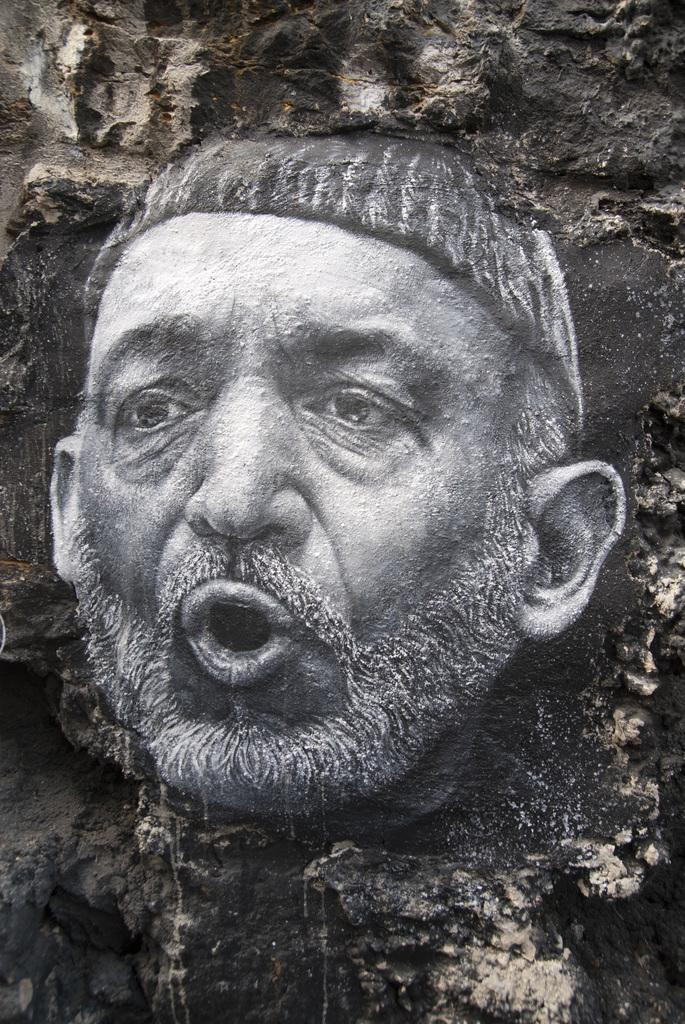What is the main subject of the image? There is a sculpture in the image. Can you describe the sculpture? The sculpture is of a person's face. Where is the sculpture located in the image? The sculpture is on the wall. How many geese are swimming in the stream depicted in the image? There is no stream or geese present in the image; it features a sculpture of a person's face on the wall. 